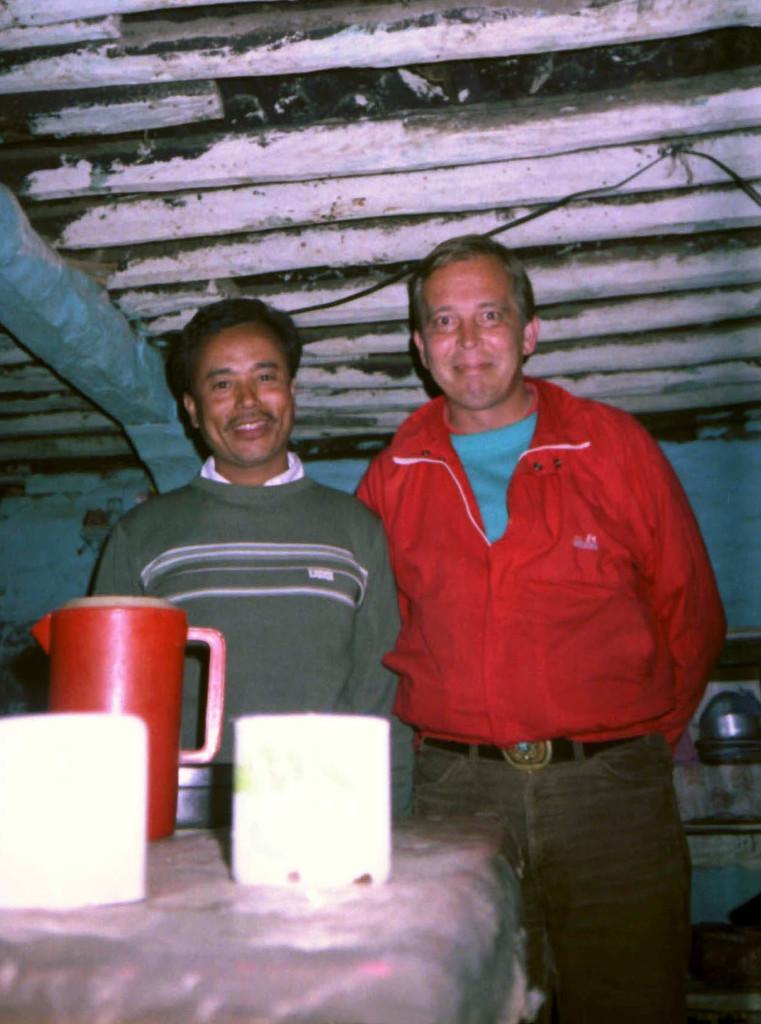In one or two sentences, can you explain what this image depicts? In this image, we can see the table, on the table, we can see a water jug and some objects. We can see two men standing, at the top we can see the shed. 